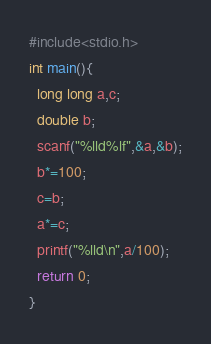<code> <loc_0><loc_0><loc_500><loc_500><_C_>#include<stdio.h>
int main(){
  long long a,c;
  double b;
  scanf("%lld%lf",&a,&b);
  b*=100;
  c=b;
  a*=c;
  printf("%lld\n",a/100);
  return 0;
}
</code> 